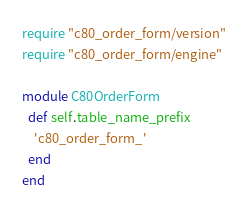<code> <loc_0><loc_0><loc_500><loc_500><_Ruby_>require "c80_order_form/version"
require "c80_order_form/engine"

module C80OrderForm
  def self.table_name_prefix
    'c80_order_form_'
  end
end
</code> 